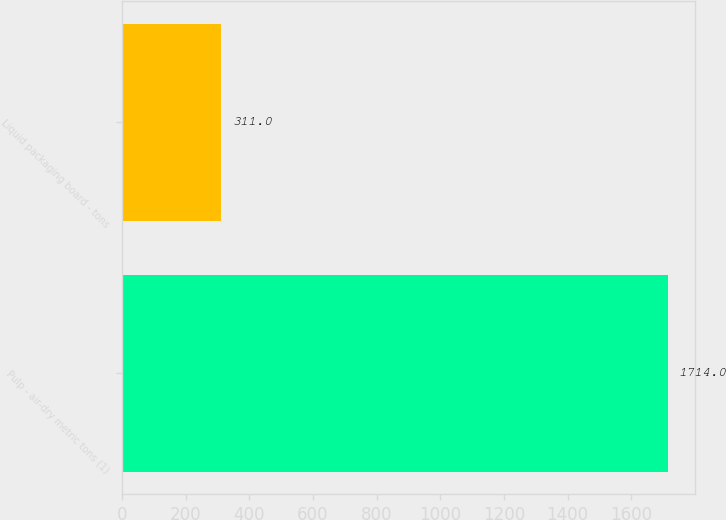Convert chart. <chart><loc_0><loc_0><loc_500><loc_500><bar_chart><fcel>Pulp - air-dry metric tons (1)<fcel>Liquid packaging board - tons<nl><fcel>1714<fcel>311<nl></chart> 